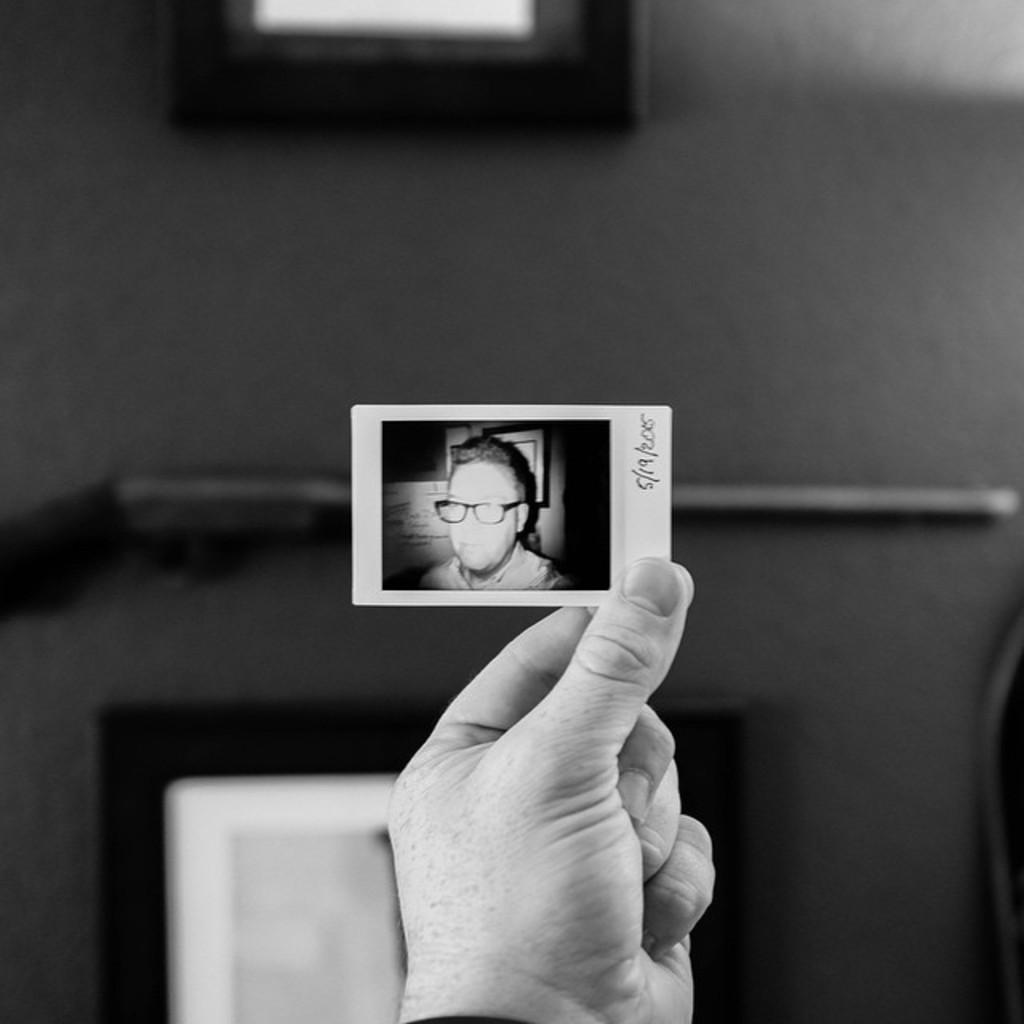What is the main subject of the image? There is a person in the image. What is the person holding in the image? The person is holding a picture. What can be seen in the picture? The picture is of another person. How many sticks are being used by the person in the image? There are no sticks present in the image. Is the person in the image a spy? There is no information in the image to suggest that the person is a spy. 